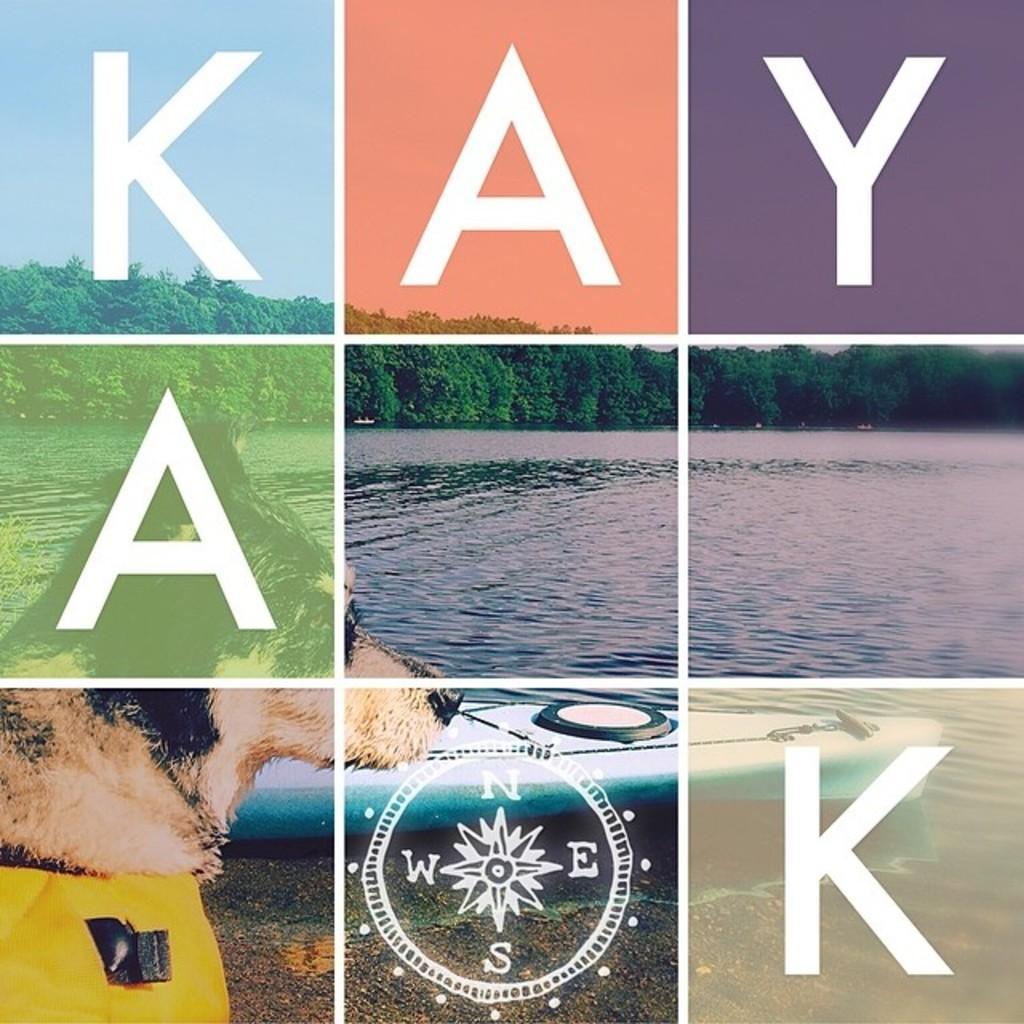Describe this image in one or two sentences. In this image I can see the dog which is on the ground. To the side of the dog I can see the water and the trees. In the back there is a sky. This is a collage image and I can see alphabets in this image. 